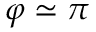Convert formula to latex. <formula><loc_0><loc_0><loc_500><loc_500>\varphi \simeq \pi</formula> 